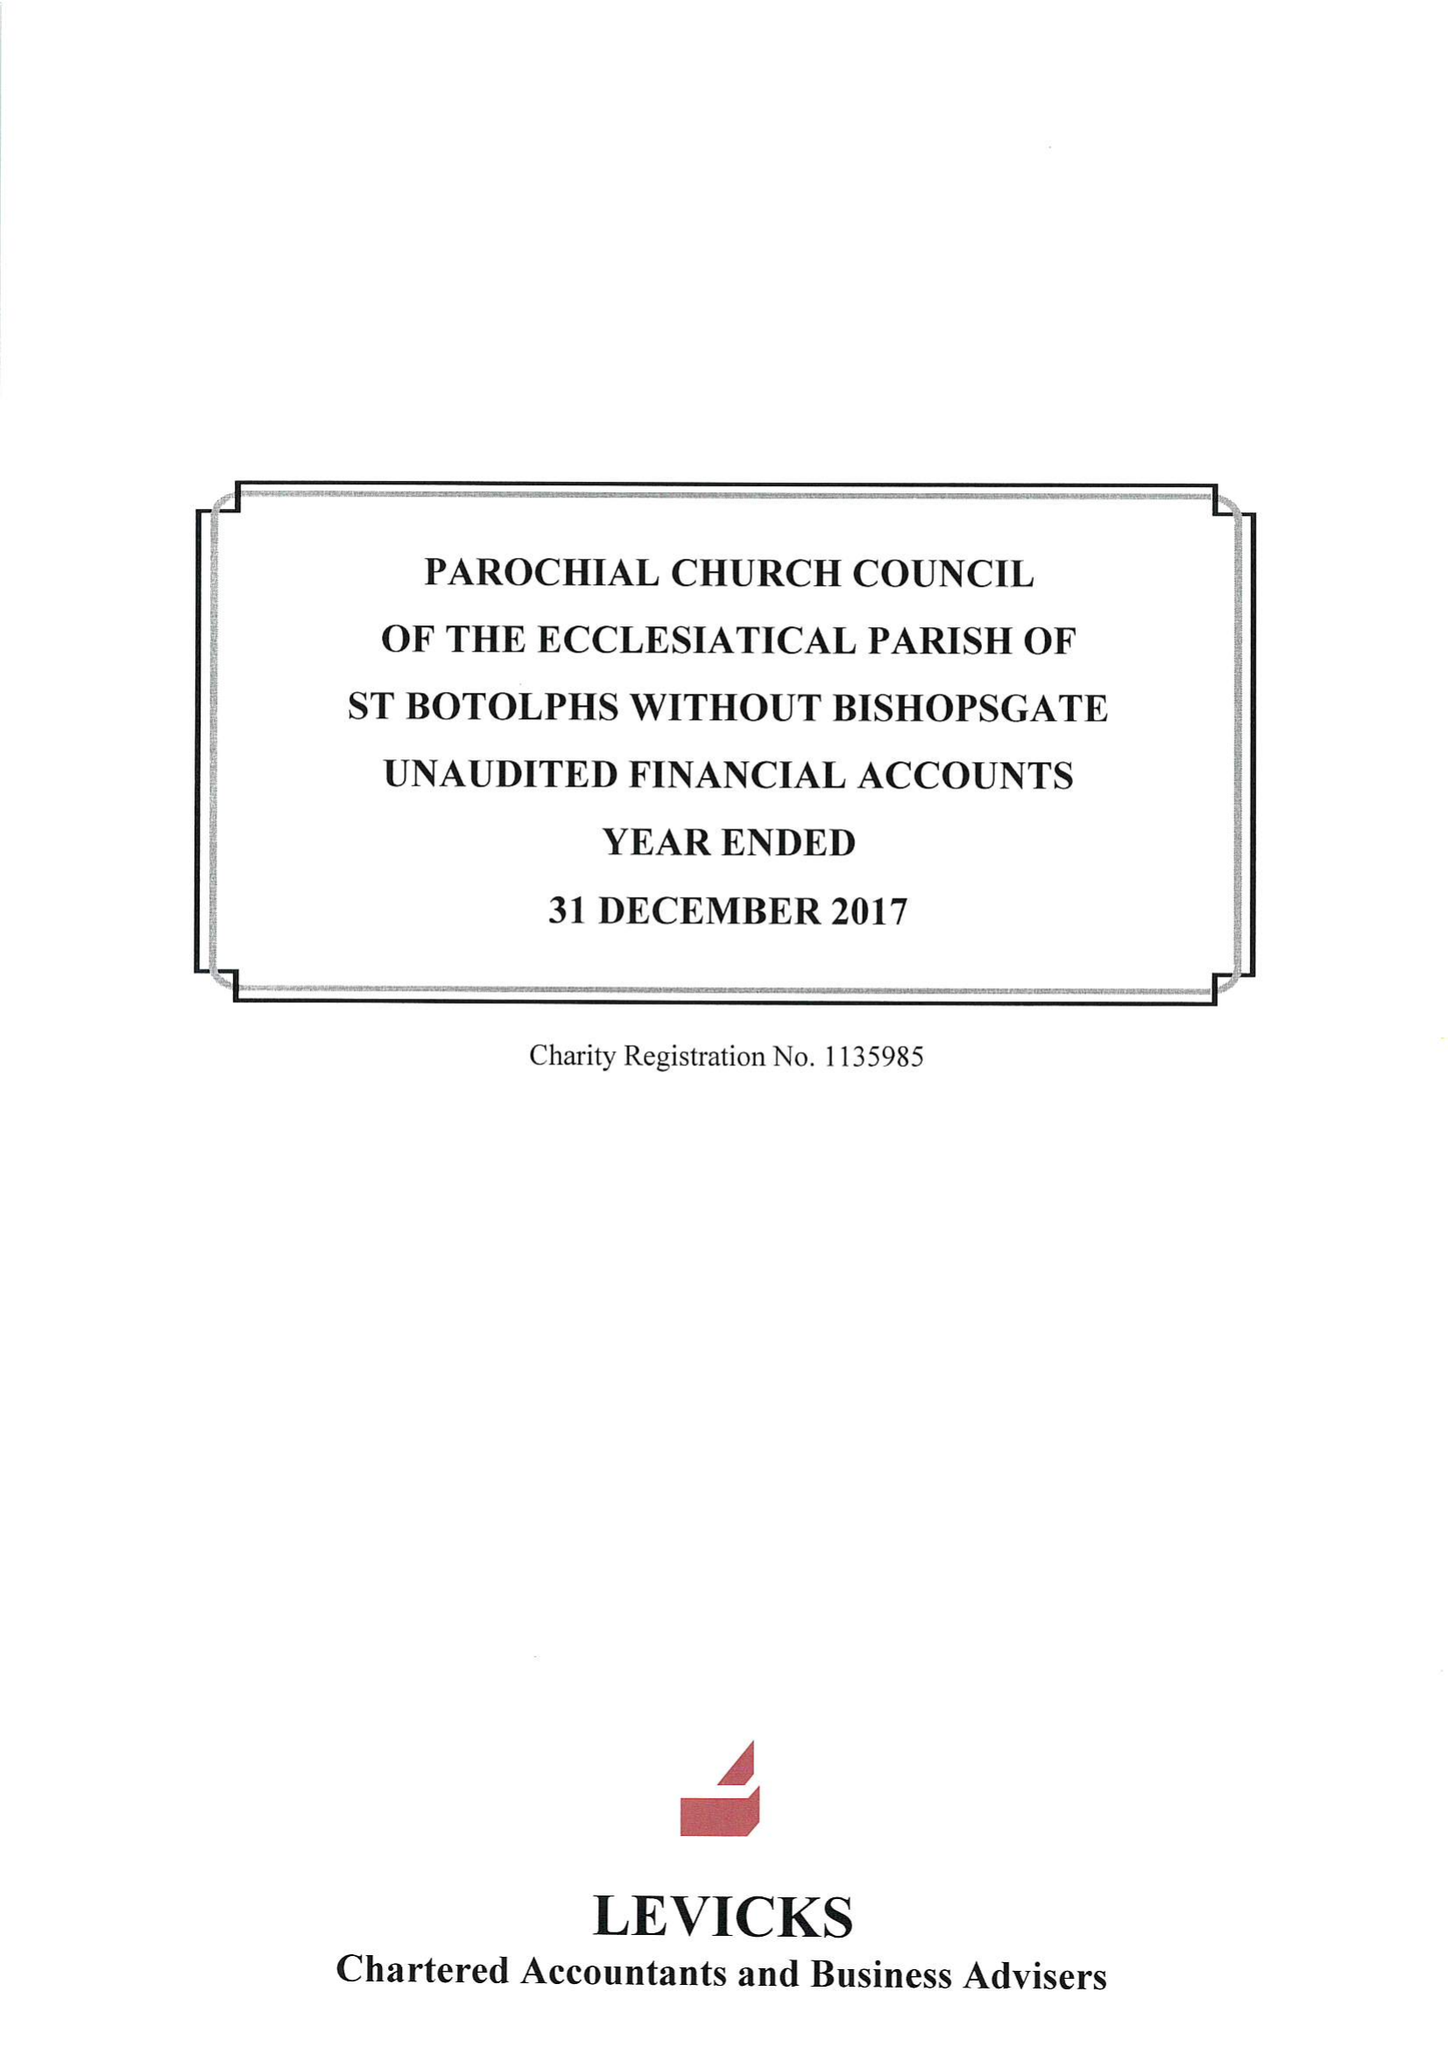What is the value for the report_date?
Answer the question using a single word or phrase. 2017-12-31 